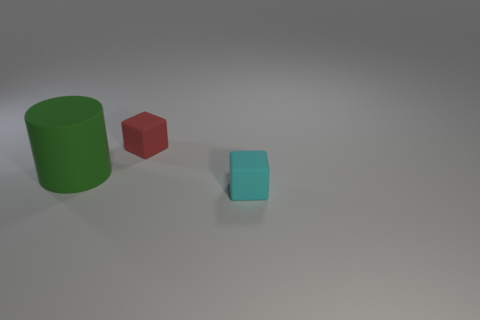Are there any other things that are the same size as the green cylinder?
Your response must be concise. No. What number of small cyan objects are the same shape as the red object?
Provide a short and direct response. 1. The red block that is the same material as the big object is what size?
Keep it short and to the point. Small. Does the cyan object have the same size as the red object?
Make the answer very short. Yes. Are there any tiny blue rubber things?
Offer a terse response. No. What is the size of the thing behind the large green matte thing that is left of the rubber thing that is behind the big green cylinder?
Give a very brief answer. Small. What number of other big things are made of the same material as the red object?
Your response must be concise. 1. What number of red matte blocks have the same size as the cyan thing?
Give a very brief answer. 1. How many things are big green objects or small cyan balls?
Offer a terse response. 1. The tiny red object has what shape?
Your answer should be very brief. Cube. 